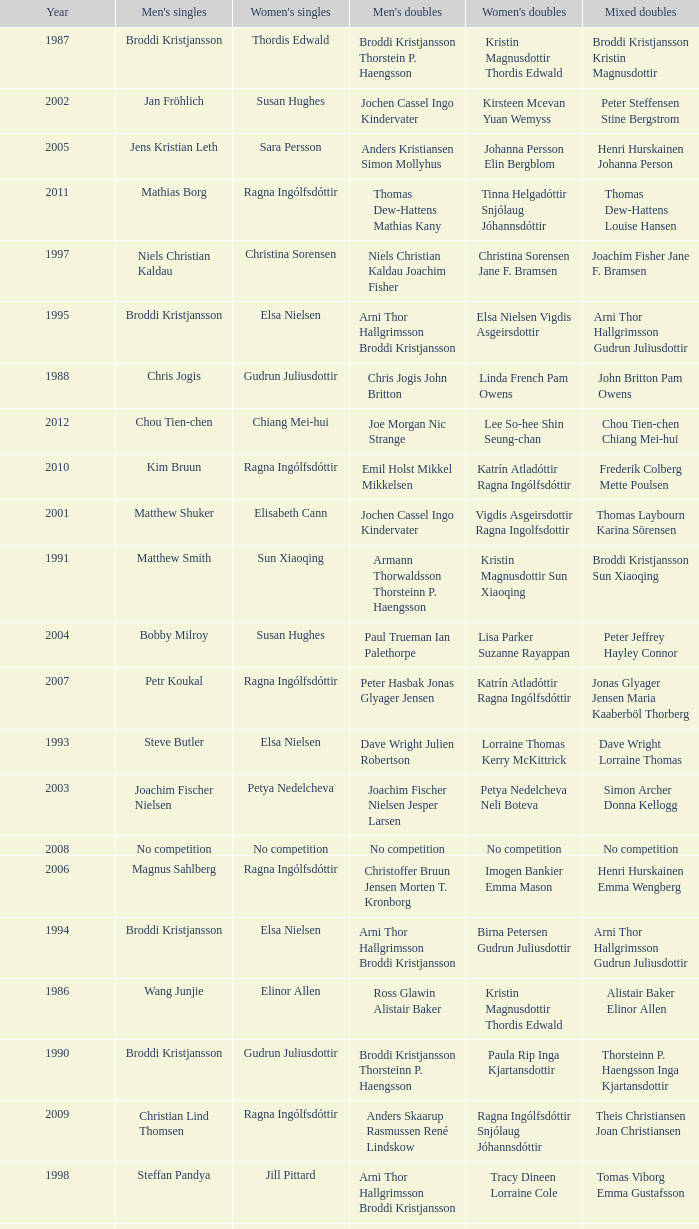In what mixed doubles did Niels Christian Kaldau play in men's singles? Joachim Fisher Jane F. Bramsen. 